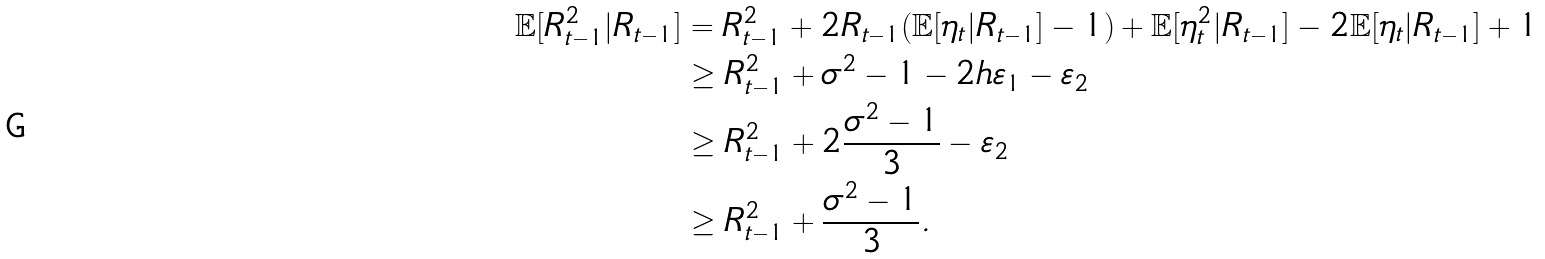Convert formula to latex. <formula><loc_0><loc_0><loc_500><loc_500>\mathbb { E } [ R ^ { 2 } _ { t - 1 } | R _ { t - 1 } ] & = R ^ { 2 } _ { t - 1 } + 2 R _ { t - 1 } ( \mathbb { E } [ \eta _ { t } | R _ { t - 1 } ] - 1 ) + \mathbb { E } [ \eta ^ { 2 } _ { t } | R _ { t - 1 } ] - 2 \mathbb { E } [ \eta _ { t } | R _ { t - 1 } ] + 1 \\ & \geq R ^ { 2 } _ { t - 1 } + \sigma ^ { 2 } - 1 - 2 h \varepsilon _ { 1 } - \varepsilon _ { 2 } \\ & \geq R ^ { 2 } _ { t - 1 } + 2 \frac { \sigma ^ { 2 } - 1 } { 3 } - \varepsilon _ { 2 } \\ & \geq R ^ { 2 } _ { t - 1 } + \frac { \sigma ^ { 2 } - 1 } { 3 } .</formula> 